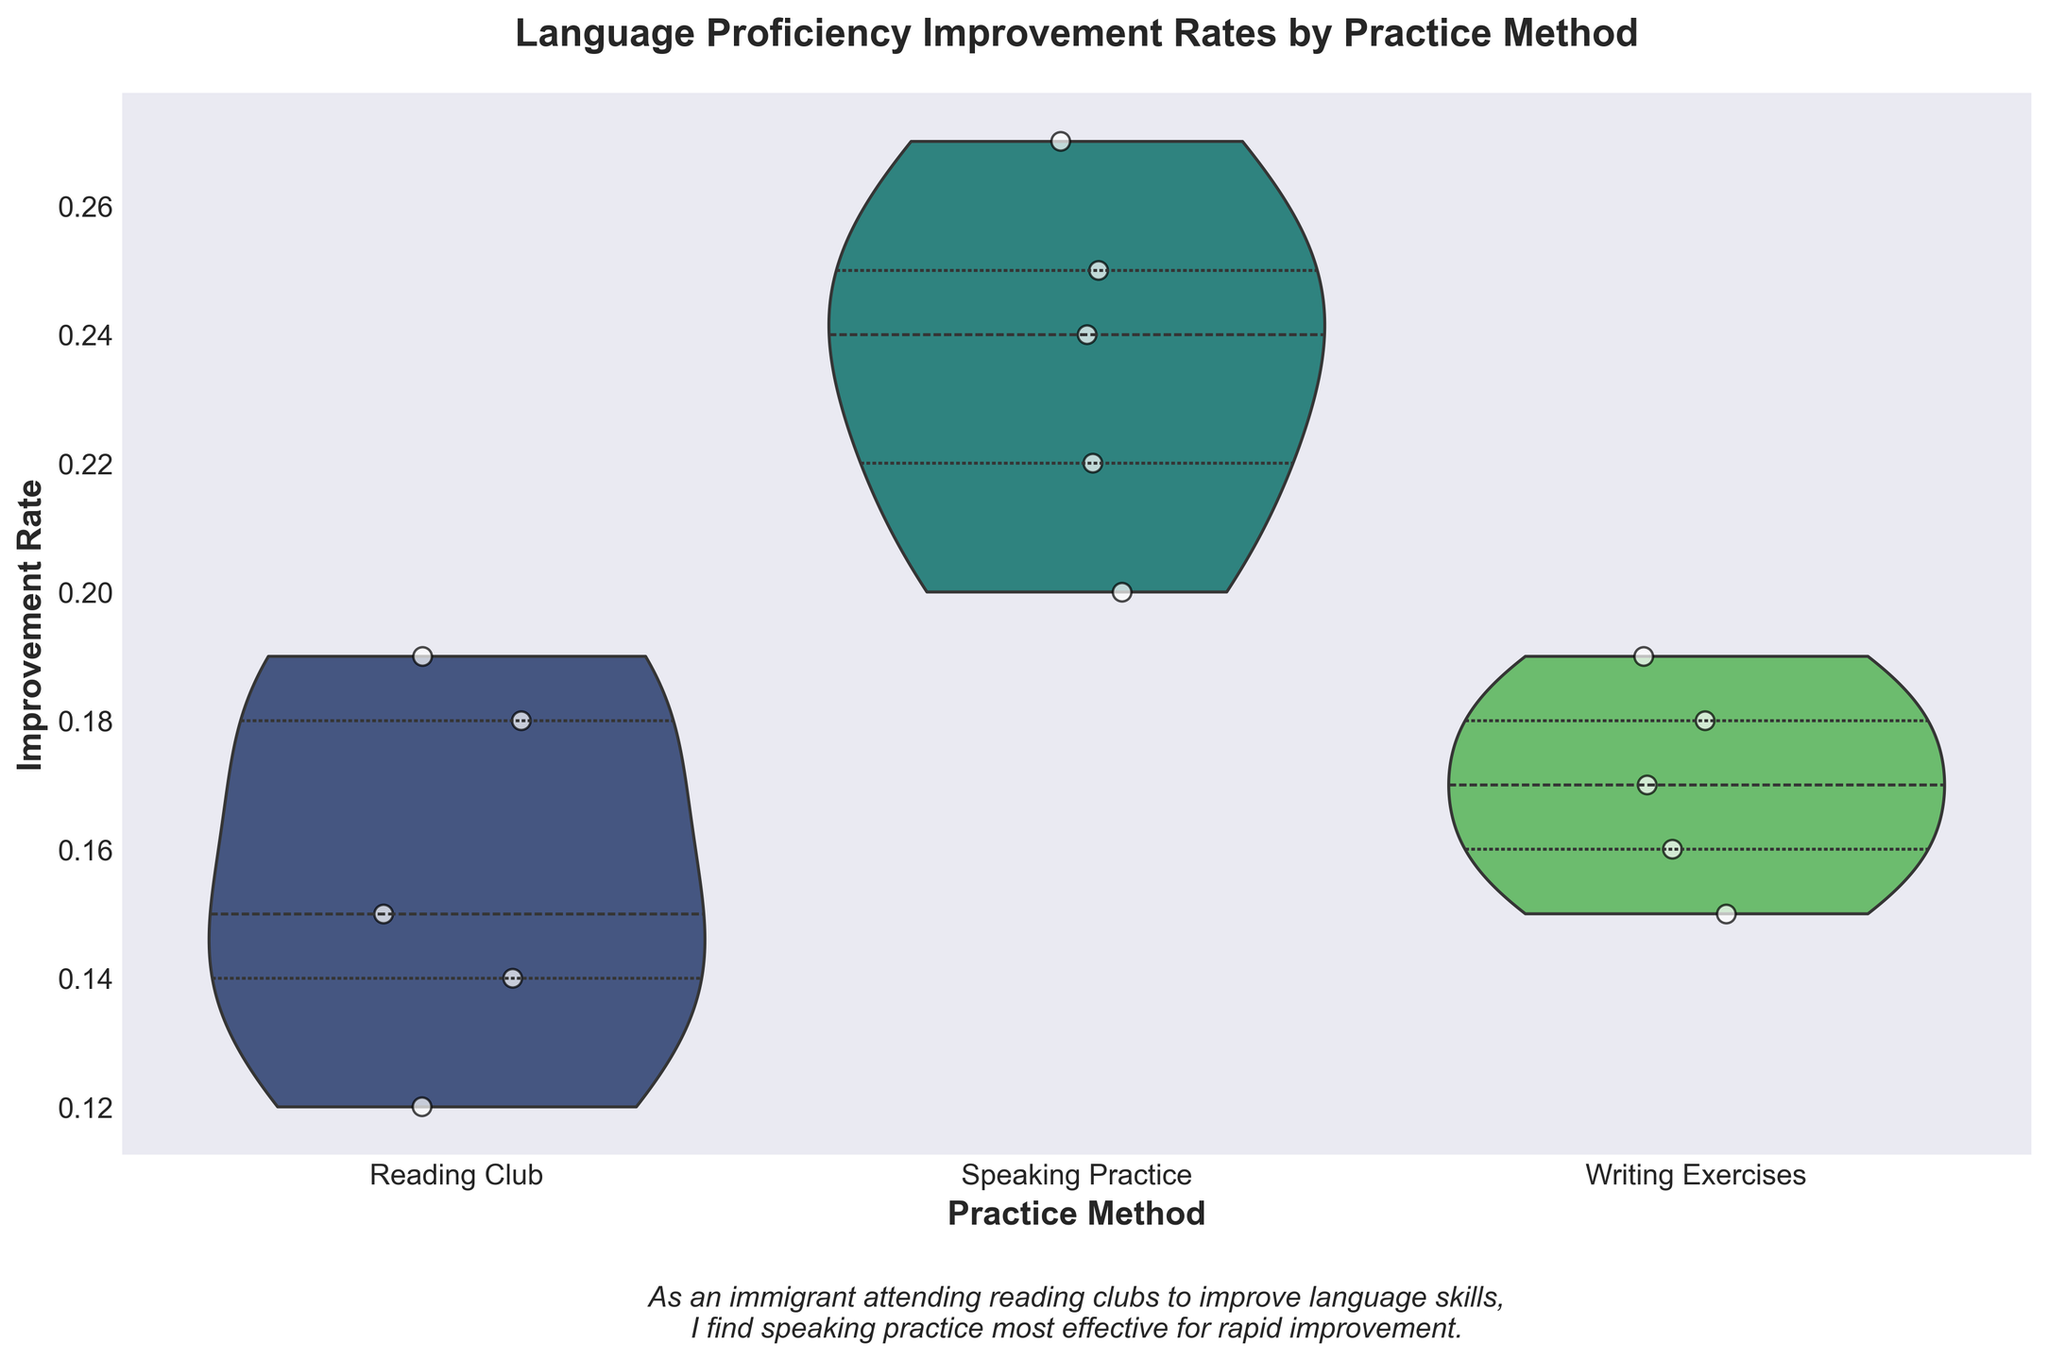What is the title of the figure? The title of the figure is written at the top and it reads "Language Proficiency Improvement Rates by Practice Method".
Answer: Language Proficiency Improvement Rates by Practice Method What are the labels for the x-axis and y-axis? The x-axis is labeled 'Practice Method', and the y-axis is labeled 'Improvement Rate'.
Answer: Practice Method, Improvement Rate Which practice method has the highest median improvement rate? By looking at the thick bar within each violin plot, it represents the median. The method 'Speaking Practice' has the thick bar positioned higher along the y-axis, indicating the highest median improvement rate.
Answer: Speaking Practice Which practice method shows the most spread in improvement rates? The width of the violin plots indicates the distribution spread. 'Speaking Practice' shows a wider plot compared to others, suggesting a larger spread in improvement rates.
Answer: Speaking Practice How many people attended writing exercises? The number of white scatter dots within the 'Writing Exercises' violin plot represents the attendees. There are 5 dots depicting 5 people.
Answer: 5 What is the range of improvement rates for the 'Reading Club' method? The range is determined by the highest and lowest points that the violin extends to. For 'Reading Club', the range is from approximately 0.12 to 0.19.
Answer: 0.12 - 0.19 Which practice method has the smallest spread in improvement rates? The smallest spread can be identified by the most narrow or compact violin plot. 'Reading Club' is the most compact among the three methods.
Answer: Reading Club Compare the improvement rates between 'Person_A' in 'Reading Club' and 'Speaking Practice'. 'Person_A' has an improvement rate of 0.15 for Reading Club and 0.22 for Speaking Practice. Comparing these, the rate for Speaking Practice is higher.
Answer: Speaking Practice What is the interquartile range (IQR) for the 'Writing Exercises' method? The interquartile range (IQR) is represented by the area between the two thick horizontal bars within the violin plot. For 'Writing Exercises', the lower bar is around 0.15 and the upper one is near 0.19. The IQR is 0.19 - 0.15 = 0.04.
Answer: 0.04 